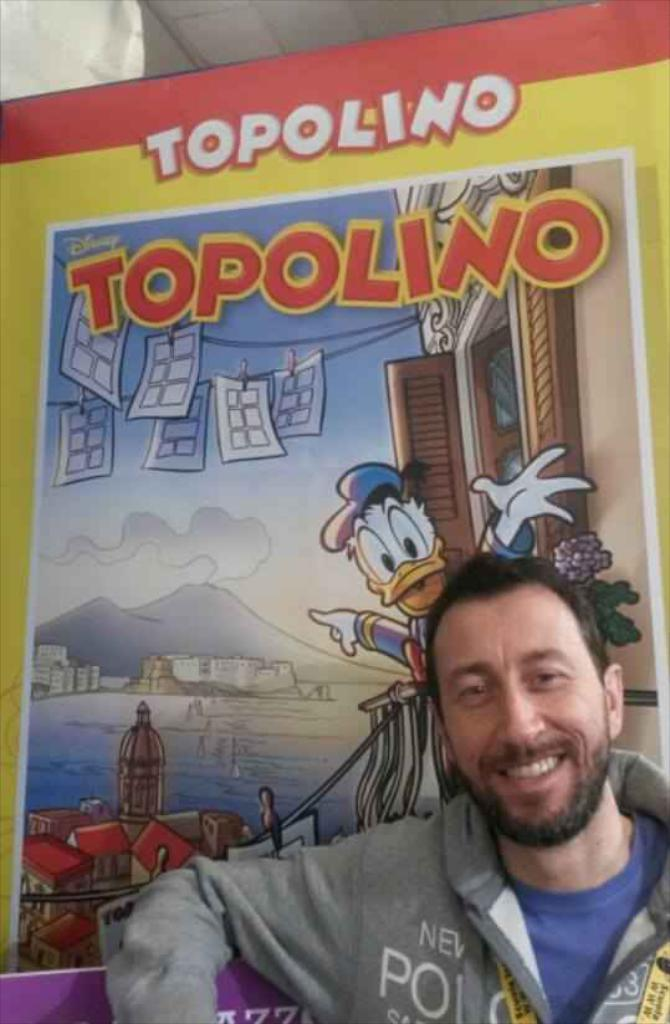Who is present in the image? There is a man in the image. Where is the man located in the image? The man is on the right side of the image. What is the man wearing? The man is wearing a blue t-shirt and a grey jacket. What is the man's facial expression? The man is smiling. What else can be seen in the image besides the man? There is a poster in the image. What is special about the poster? The poster has animations on it and there is writing on the poster. What type of surprise can be seen on the man's wrist in the image? There is no surprise or any object on the man's wrist in the image. 